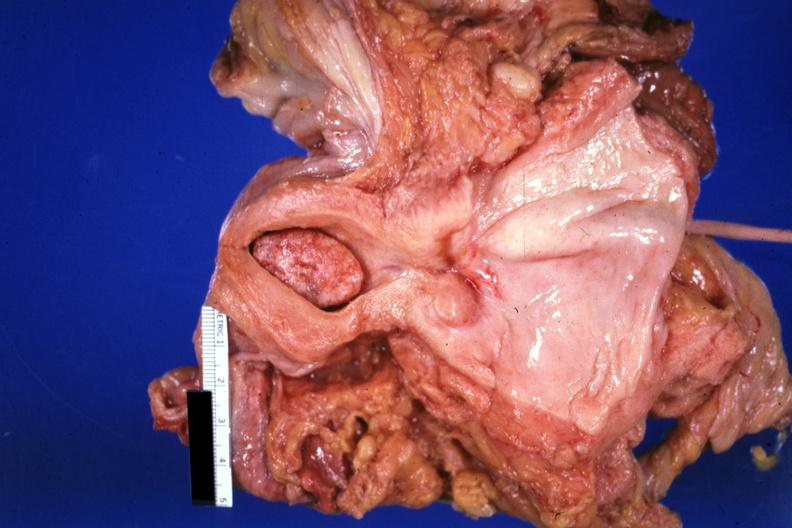where does this part belong to?
Answer the question using a single word or phrase. Female reproductive system 